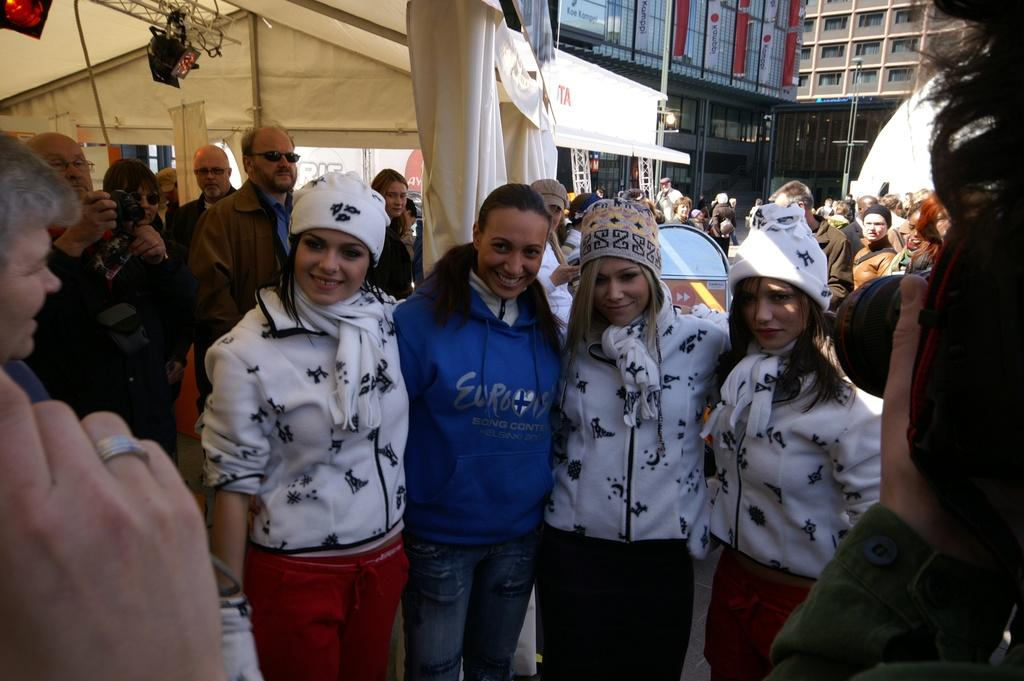What is happening in the image? There are people standing in the image. Can you describe the clothing of the people? The people are wearing different color dresses. What is one person holding in the image? One person is holding a camera. What can be seen in the background of the image? Buildings, windows, tents, poles, and lights are visible in the background. Reasoning: Let' Let's think step by step in order to produce the conversation. We start by identifying the main subjects in the image, which are the people standing. Then, we describe their clothing and the object one person is holding, which is a camera. Next, we expand the conversation to include the background, mentioning the various elements that can be seen. Each question is designed to elicit a specific detail about the image that is known from the provided facts. Absurd Question/Answer: What is the reason for the chain hanging from the tents in the image? There is no chain hanging from the tents in the image. How many women are present in the image? The provided facts do not specify the gender of the people in the image, so we cannot definitively answer this question. --- Facts: 1. There is a car in the image. 2. The car is red. 3. The car has four wheels. 4. There is a road in the image. 5. The road is paved. 6. There are trees on the side of the road. 7. The sky is visible in the image. Absurd Topics: fish, ocean, boat Conversation: What is the main subject of the image? The main subject of the image is a car. Can you describe the car in the image? The car is red and has four wheels. What can be seen in the background of the image? There is a road, trees, and the sky visible in the image. What is the condition of the road in the image? The road is paved. Reasoning: Let's think step by step in order to produce the conversation. We start by identifying the main subject of the image, which is the car. Then, we describe the car's color and the number of wheels it has. Next, we expand the conversation 